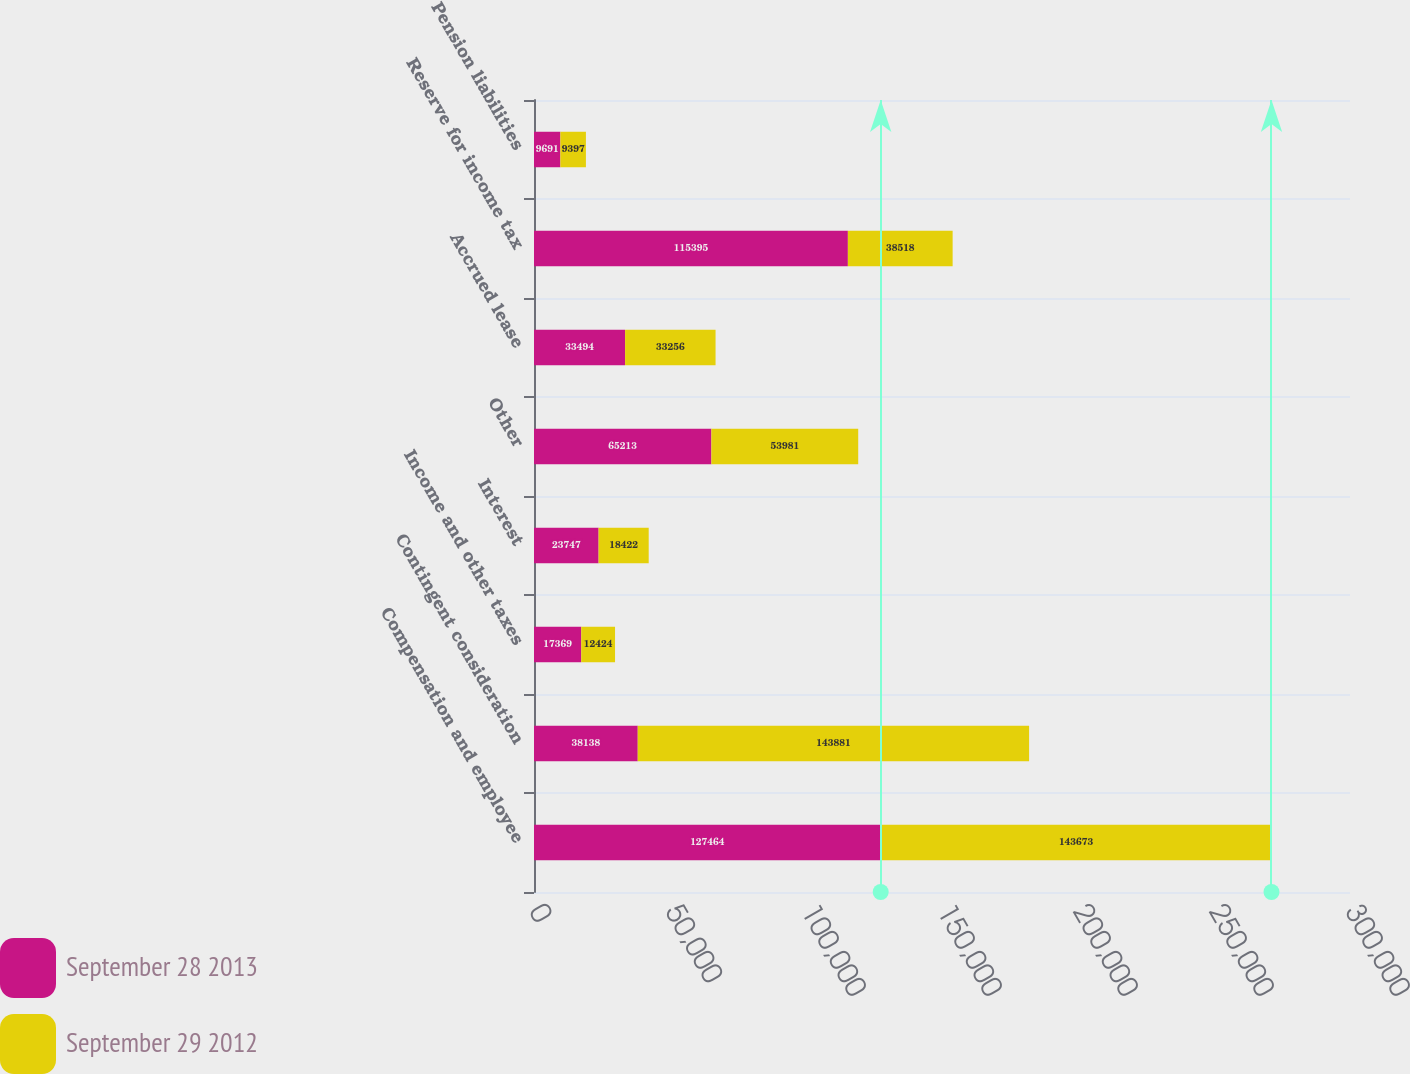Convert chart to OTSL. <chart><loc_0><loc_0><loc_500><loc_500><stacked_bar_chart><ecel><fcel>Compensation and employee<fcel>Contingent consideration<fcel>Income and other taxes<fcel>Interest<fcel>Other<fcel>Accrued lease<fcel>Reserve for income tax<fcel>Pension liabilities<nl><fcel>September 28 2013<fcel>127464<fcel>38138<fcel>17369<fcel>23747<fcel>65213<fcel>33494<fcel>115395<fcel>9691<nl><fcel>September 29 2012<fcel>143673<fcel>143881<fcel>12424<fcel>18422<fcel>53981<fcel>33256<fcel>38518<fcel>9397<nl></chart> 